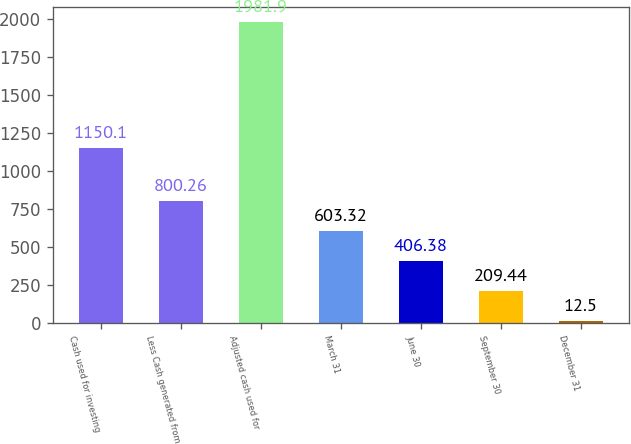<chart> <loc_0><loc_0><loc_500><loc_500><bar_chart><fcel>Cash used for investing<fcel>Less Cash generated from<fcel>Adjusted cash used for<fcel>March 31<fcel>June 30<fcel>September 30<fcel>December 31<nl><fcel>1150.1<fcel>800.26<fcel>1981.9<fcel>603.32<fcel>406.38<fcel>209.44<fcel>12.5<nl></chart> 